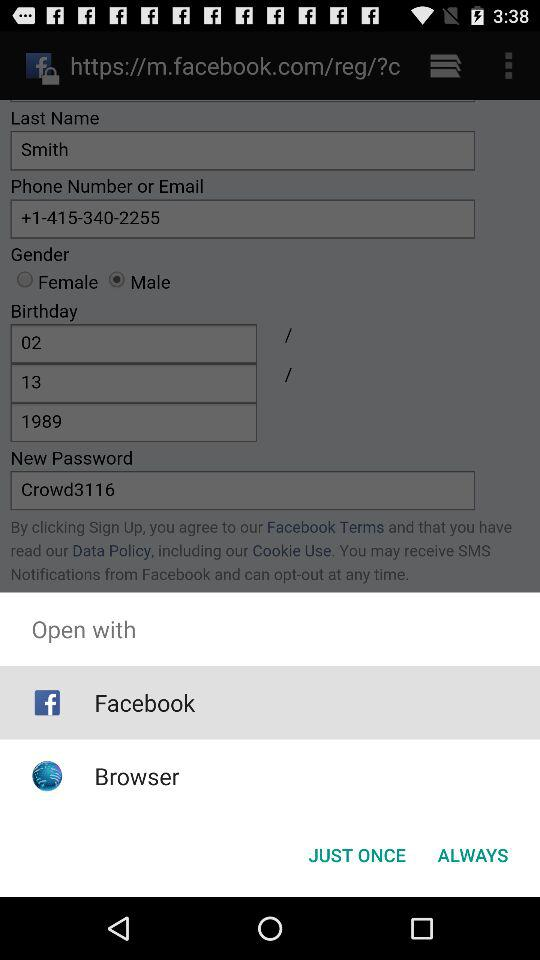Through what application can we open? We can open it with "Facebook" and "Browser". 